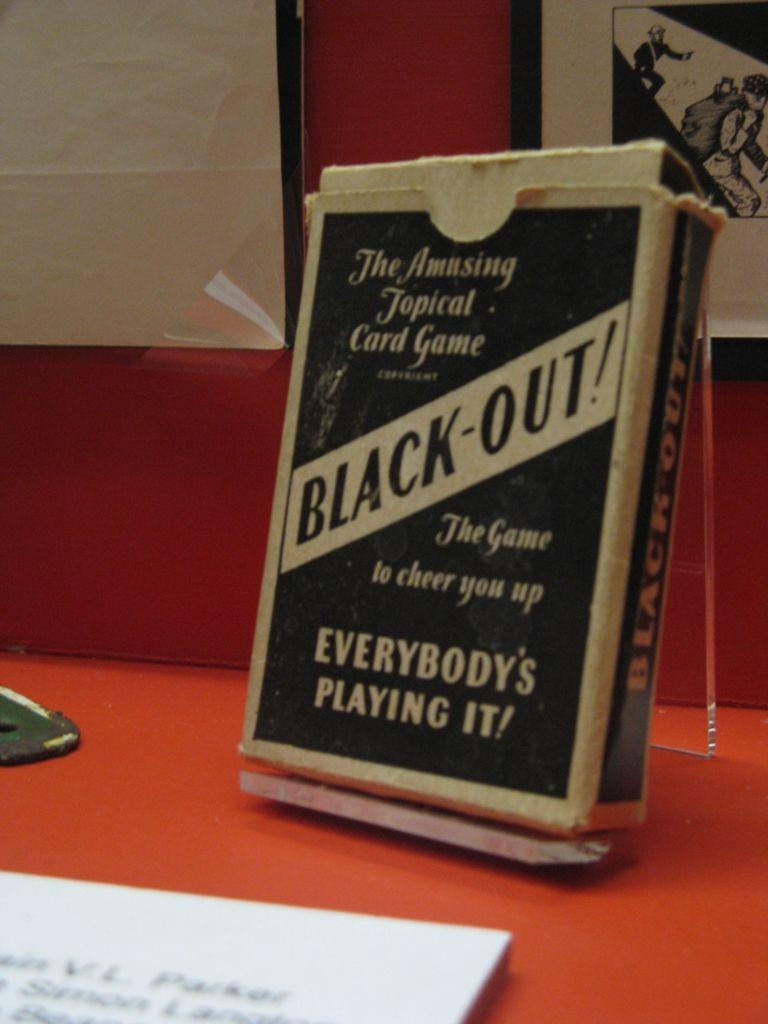<image>
Describe the image concisely. a book that is called Black Out sits on a table 